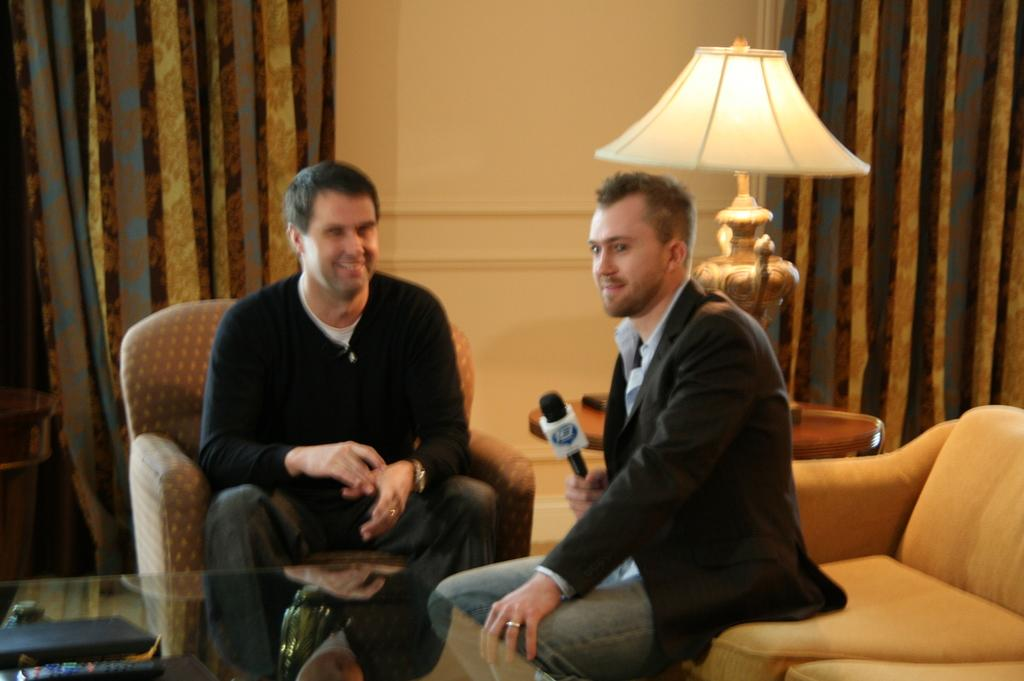How many people are seated in the image? There are two men seated in the image. What is one of the men holding in his hand? One man is holding a microphone in his hand. What type of furniture can be seen in the image? There are chairs in the image. What can be seen providing illumination in the image? There is a light visible in the image. What type of window treatment is present in the image? There are curtains hanging in the image. What type of pancake is being served during the game in the image? There is no pancake or game present in the image. How many bags of popcorn are visible in the image? There are no bags of popcorn visible in the image. 